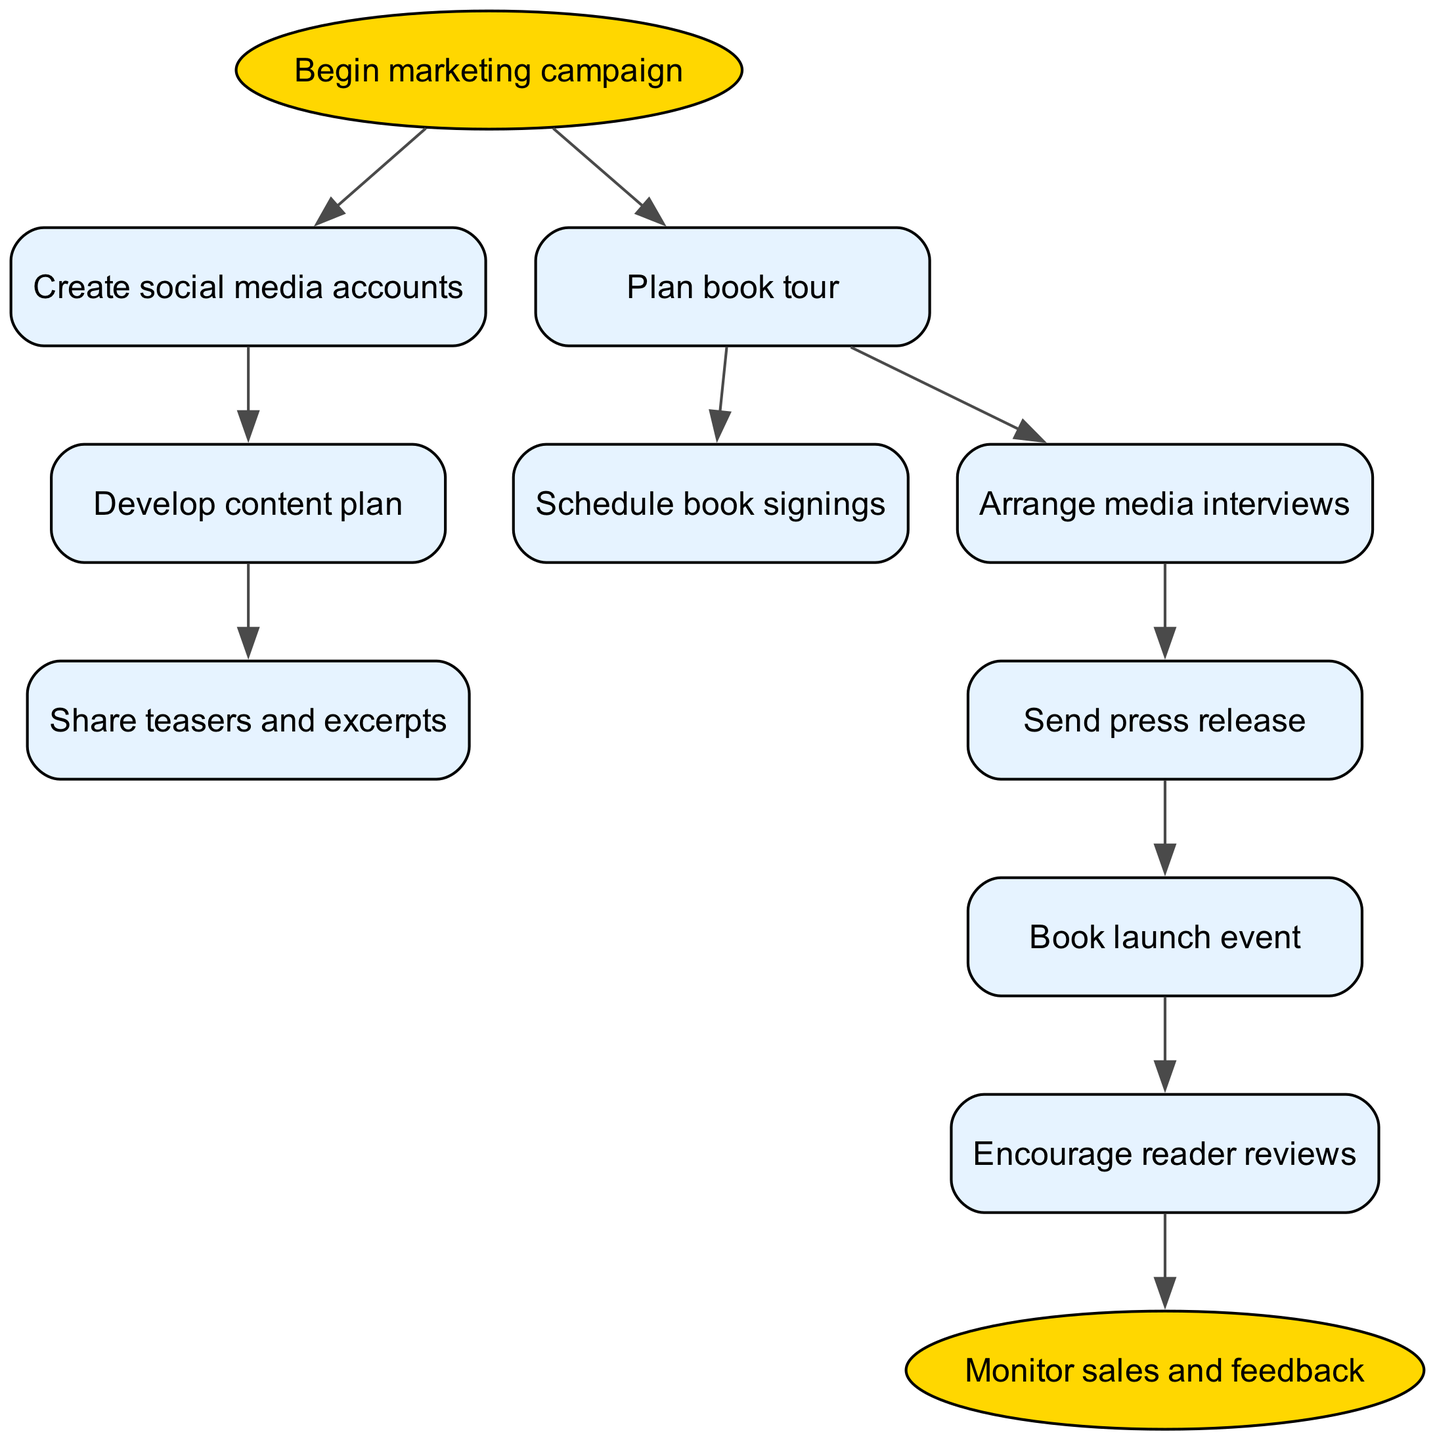What is the first step in the marketing campaign? The first step in the marketing campaign, indicated by the starting node, is to "Begin marketing campaign." This is the initial action that sets the whole process in motion.
Answer: Begin marketing campaign How many nodes are in the diagram? To find the total number of nodes, we count the elements listed in the data provided, which includes both beginning and ending nodes, as well as all the actions in between. There are 10 nodes in total.
Answer: 10 What follows after creating social media accounts? The flow shows that after "Create social media accounts," the next step is "Develop content plan." This direct connection between the two nodes indicates the sequential nature of the marketing plan.
Answer: Develop content plan How many book signings are scheduled after the book tour? According to the flow, the action "Schedule book signings" directly follows from "Plan book tour." The presence of a connection indicates that scheduling signings is one of the planned actions after the tour is set up.
Answer: Schedule book signings Which action comes directly after sending a press release? In the flow chart, the immediate step following "Send press release" is "Book launch event." This indicates that sending out the press release is part of the lead-up to the launch event.
Answer: Book launch event What happens after the book launch event? After the "Book launch event," the process leads to "Encourage reader reviews." This indicates a focus on gathering feedback and responses from readers to promote the book.
Answer: Encourage reader reviews Which two nodes branch from the book tour? The two actions that stem from "Plan book tour" are "Schedule book signings" and "Arrange media interviews." This shows that the book tour involves multiple promotional strategies.
Answer: Schedule book signings and Arrange media interviews What final action is taken in the strategy? The last step in the diagram is "Monitor sales and feedback." This indicates that after all promotional activities, the focus will shift to assessing the success of the campaign based on sales figures and reader responses.
Answer: Monitor sales and feedback What type of media actions are linked to interviews? The flow chart shows that "Arrange media interviews" is followed by "Send press release." This connection highlights that interviews are a precursor to further publicity actions involving press communication.
Answer: Send press release 